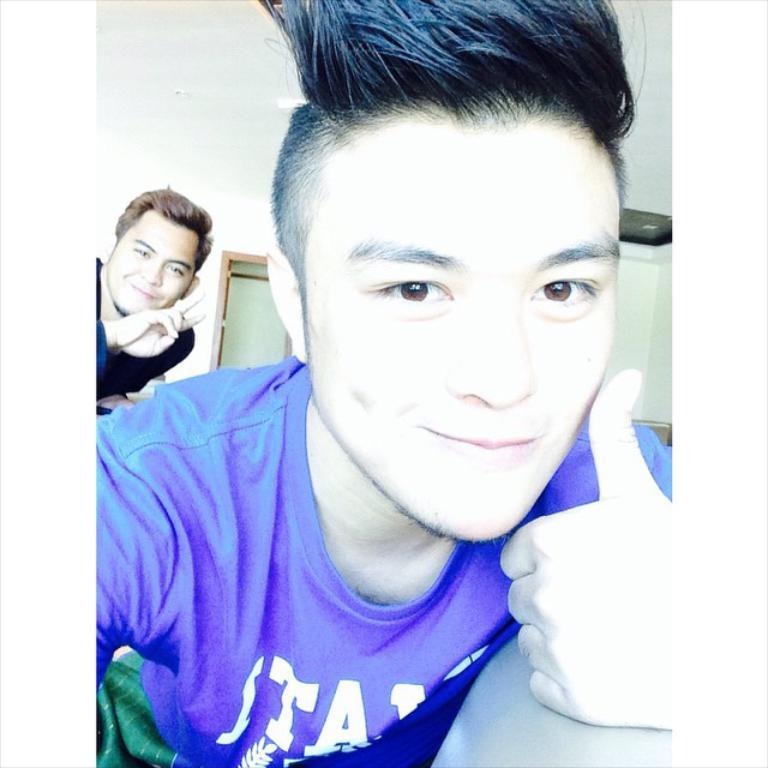How many men are present in the image? There are two men in the image. What is the facial expression of the men in the image? Both men are smiling. Can you describe the positioning of the men in the image? There is a man in the middle of the image. What color is the T-shirt worn by the man in the middle? The man in the middle is wearing a blue color T-shirt. Where can the harbor be seen in the image? There is no harbor present in the image. What type of watch is the man in the middle wearing? The man in the middle is not wearing a watch in the image. 